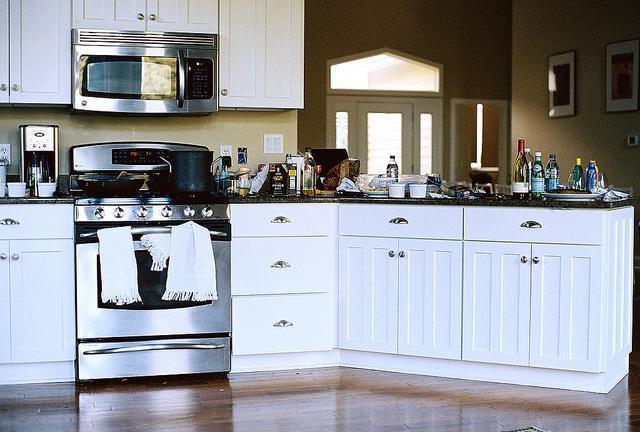How many towels are there?
Give a very brief answer. 2. How many sockets are shown?
Give a very brief answer. 2. 